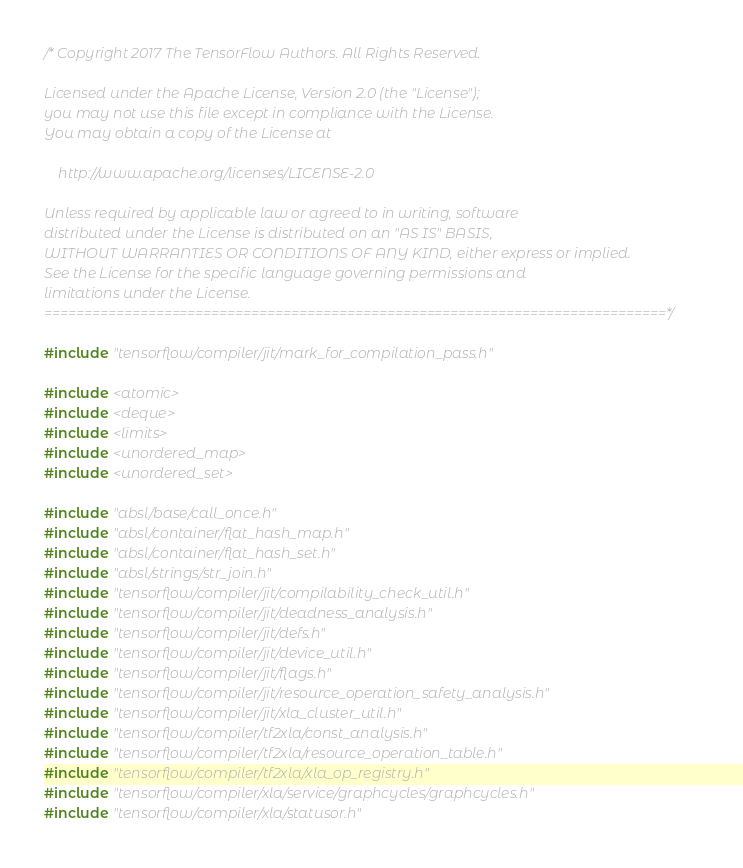<code> <loc_0><loc_0><loc_500><loc_500><_C++_>/* Copyright 2017 The TensorFlow Authors. All Rights Reserved.

Licensed under the Apache License, Version 2.0 (the "License");
you may not use this file except in compliance with the License.
You may obtain a copy of the License at

    http://www.apache.org/licenses/LICENSE-2.0

Unless required by applicable law or agreed to in writing, software
distributed under the License is distributed on an "AS IS" BASIS,
WITHOUT WARRANTIES OR CONDITIONS OF ANY KIND, either express or implied.
See the License for the specific language governing permissions and
limitations under the License.
==============================================================================*/

#include "tensorflow/compiler/jit/mark_for_compilation_pass.h"

#include <atomic>
#include <deque>
#include <limits>
#include <unordered_map>
#include <unordered_set>

#include "absl/base/call_once.h"
#include "absl/container/flat_hash_map.h"
#include "absl/container/flat_hash_set.h"
#include "absl/strings/str_join.h"
#include "tensorflow/compiler/jit/compilability_check_util.h"
#include "tensorflow/compiler/jit/deadness_analysis.h"
#include "tensorflow/compiler/jit/defs.h"
#include "tensorflow/compiler/jit/device_util.h"
#include "tensorflow/compiler/jit/flags.h"
#include "tensorflow/compiler/jit/resource_operation_safety_analysis.h"
#include "tensorflow/compiler/jit/xla_cluster_util.h"
#include "tensorflow/compiler/tf2xla/const_analysis.h"
#include "tensorflow/compiler/tf2xla/resource_operation_table.h"
#include "tensorflow/compiler/tf2xla/xla_op_registry.h"
#include "tensorflow/compiler/xla/service/graphcycles/graphcycles.h"
#include "tensorflow/compiler/xla/statusor.h"</code> 